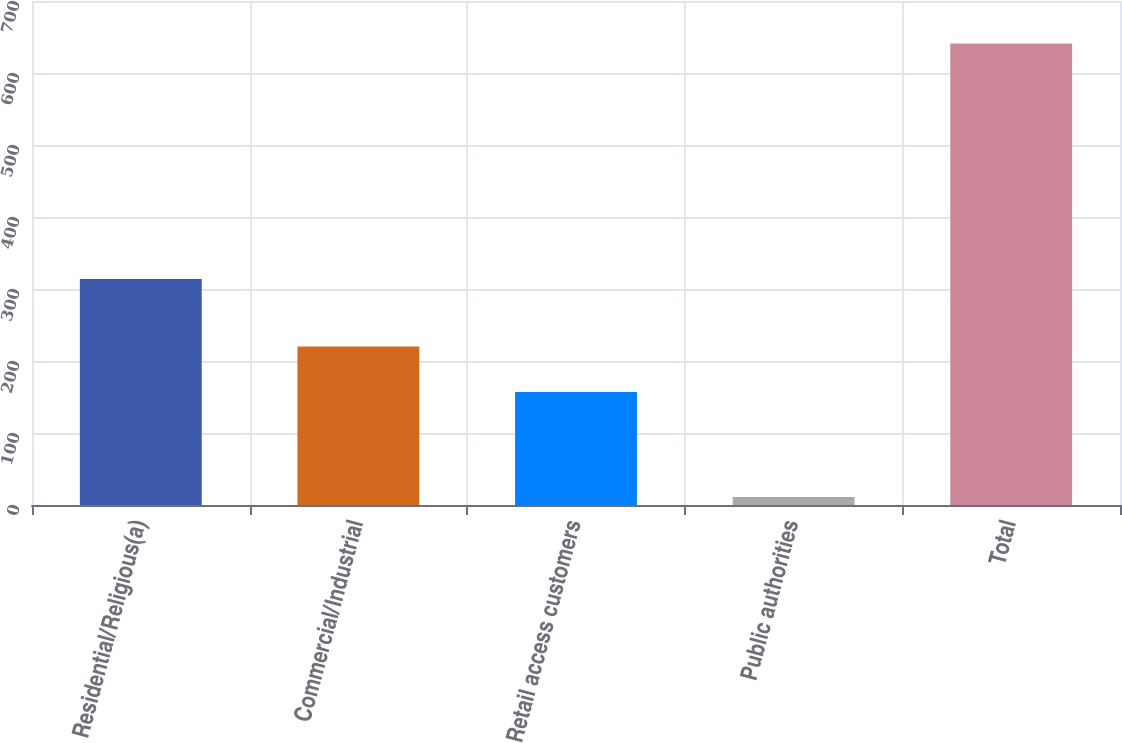<chart> <loc_0><loc_0><loc_500><loc_500><bar_chart><fcel>Residential/Religious(a)<fcel>Commercial/Industrial<fcel>Retail access customers<fcel>Public authorities<fcel>Total<nl><fcel>314<fcel>220<fcel>157<fcel>11<fcel>641<nl></chart> 